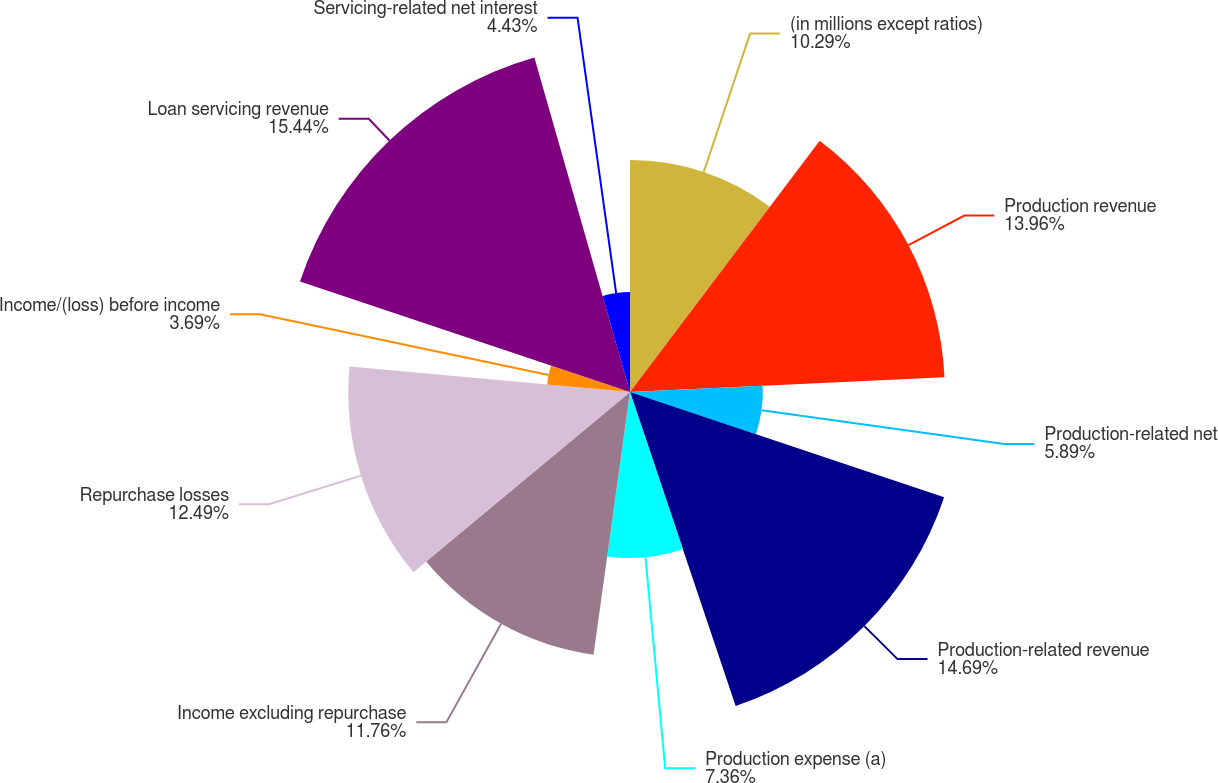<chart> <loc_0><loc_0><loc_500><loc_500><pie_chart><fcel>(in millions except ratios)<fcel>Production revenue<fcel>Production-related net<fcel>Production-related revenue<fcel>Production expense (a)<fcel>Income excluding repurchase<fcel>Repurchase losses<fcel>Income/(loss) before income<fcel>Loan servicing revenue<fcel>Servicing-related net interest<nl><fcel>10.29%<fcel>13.96%<fcel>5.89%<fcel>14.69%<fcel>7.36%<fcel>11.76%<fcel>12.49%<fcel>3.69%<fcel>15.43%<fcel>4.43%<nl></chart> 